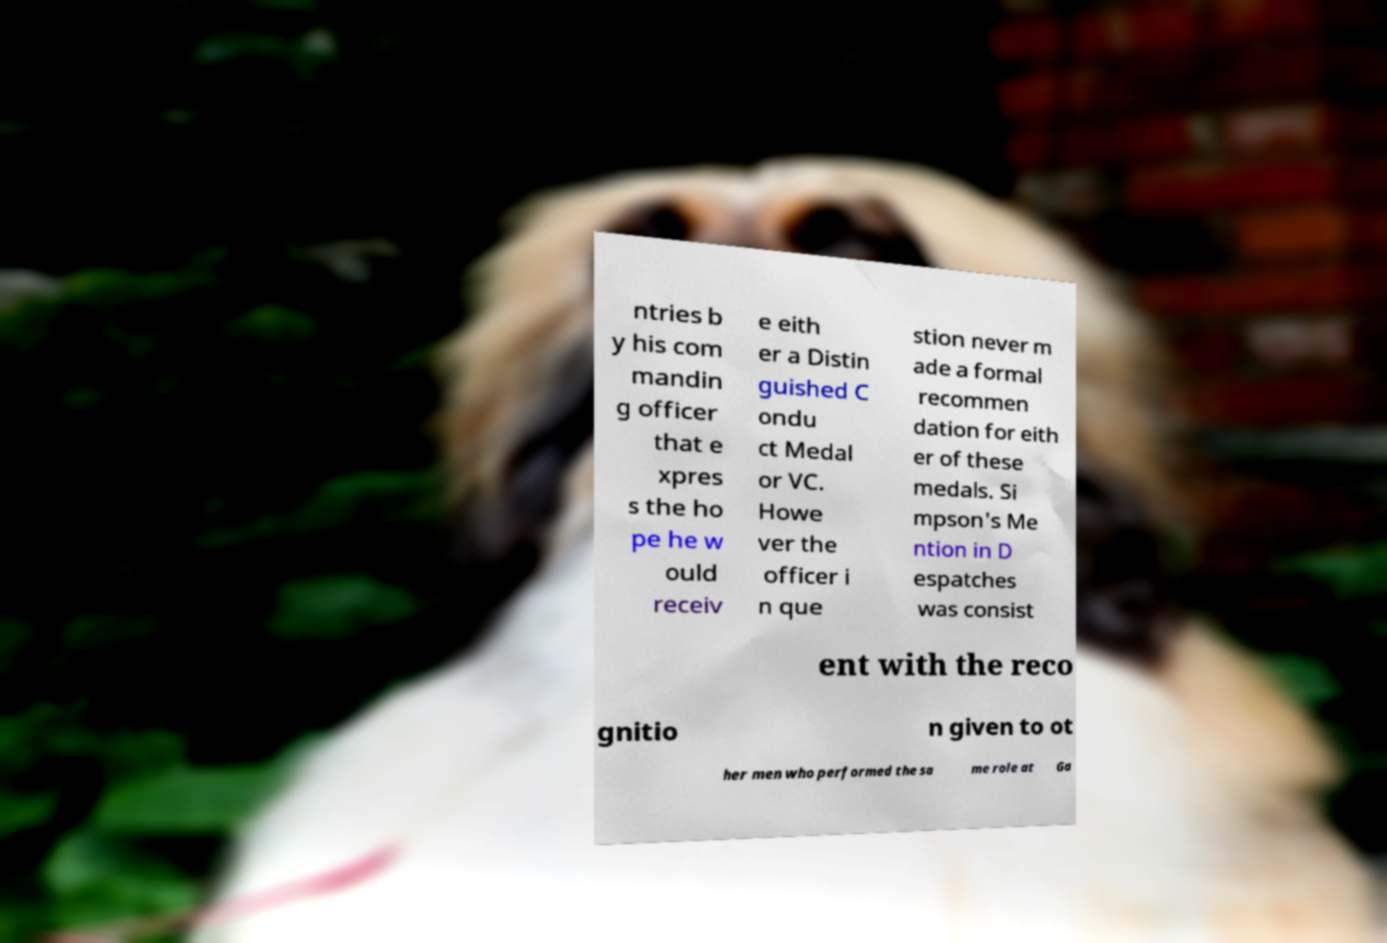Could you extract and type out the text from this image? ntries b y his com mandin g officer that e xpres s the ho pe he w ould receiv e eith er a Distin guished C ondu ct Medal or VC. Howe ver the officer i n que stion never m ade a formal recommen dation for eith er of these medals. Si mpson's Me ntion in D espatches was consist ent with the reco gnitio n given to ot her men who performed the sa me role at Ga 